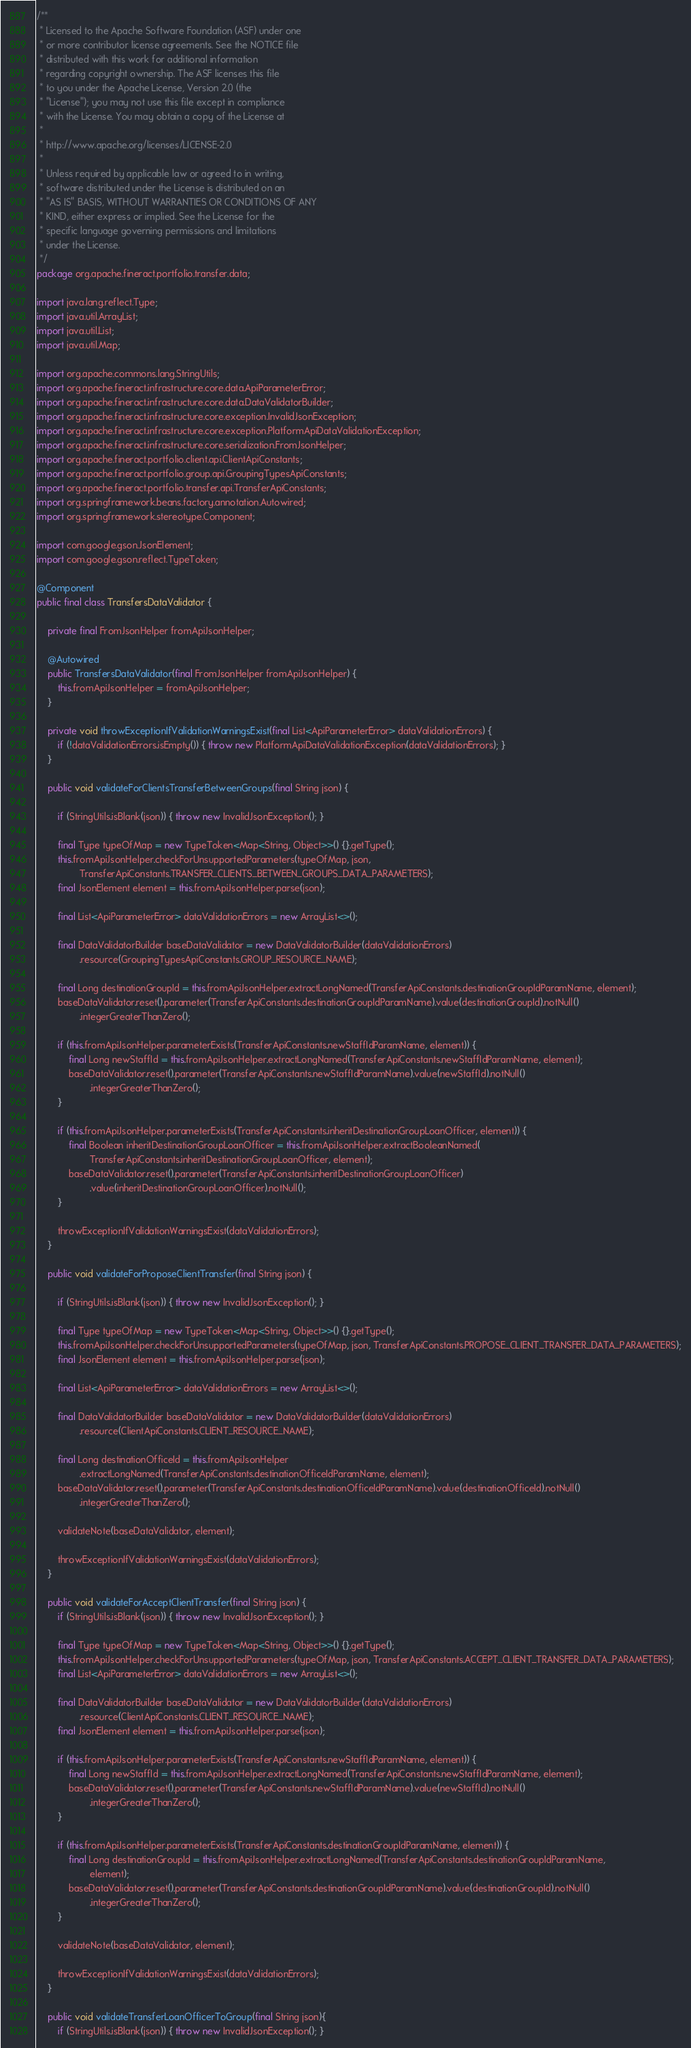<code> <loc_0><loc_0><loc_500><loc_500><_Java_>/**
 * Licensed to the Apache Software Foundation (ASF) under one
 * or more contributor license agreements. See the NOTICE file
 * distributed with this work for additional information
 * regarding copyright ownership. The ASF licenses this file
 * to you under the Apache License, Version 2.0 (the
 * "License"); you may not use this file except in compliance
 * with the License. You may obtain a copy of the License at
 *
 * http://www.apache.org/licenses/LICENSE-2.0
 *
 * Unless required by applicable law or agreed to in writing,
 * software distributed under the License is distributed on an
 * "AS IS" BASIS, WITHOUT WARRANTIES OR CONDITIONS OF ANY
 * KIND, either express or implied. See the License for the
 * specific language governing permissions and limitations
 * under the License.
 */
package org.apache.fineract.portfolio.transfer.data;

import java.lang.reflect.Type;
import java.util.ArrayList;
import java.util.List;
import java.util.Map;

import org.apache.commons.lang.StringUtils;
import org.apache.fineract.infrastructure.core.data.ApiParameterError;
import org.apache.fineract.infrastructure.core.data.DataValidatorBuilder;
import org.apache.fineract.infrastructure.core.exception.InvalidJsonException;
import org.apache.fineract.infrastructure.core.exception.PlatformApiDataValidationException;
import org.apache.fineract.infrastructure.core.serialization.FromJsonHelper;
import org.apache.fineract.portfolio.client.api.ClientApiConstants;
import org.apache.fineract.portfolio.group.api.GroupingTypesApiConstants;
import org.apache.fineract.portfolio.transfer.api.TransferApiConstants;
import org.springframework.beans.factory.annotation.Autowired;
import org.springframework.stereotype.Component;

import com.google.gson.JsonElement;
import com.google.gson.reflect.TypeToken;

@Component
public final class TransfersDataValidator {

    private final FromJsonHelper fromApiJsonHelper;

    @Autowired
    public TransfersDataValidator(final FromJsonHelper fromApiJsonHelper) {
        this.fromApiJsonHelper = fromApiJsonHelper;
    }

    private void throwExceptionIfValidationWarningsExist(final List<ApiParameterError> dataValidationErrors) {
        if (!dataValidationErrors.isEmpty()) { throw new PlatformApiDataValidationException(dataValidationErrors); }
    }

    public void validateForClientsTransferBetweenGroups(final String json) {

        if (StringUtils.isBlank(json)) { throw new InvalidJsonException(); }

        final Type typeOfMap = new TypeToken<Map<String, Object>>() {}.getType();
        this.fromApiJsonHelper.checkForUnsupportedParameters(typeOfMap, json,
                TransferApiConstants.TRANSFER_CLIENTS_BETWEEN_GROUPS_DATA_PARAMETERS);
        final JsonElement element = this.fromApiJsonHelper.parse(json);

        final List<ApiParameterError> dataValidationErrors = new ArrayList<>();

        final DataValidatorBuilder baseDataValidator = new DataValidatorBuilder(dataValidationErrors)
                .resource(GroupingTypesApiConstants.GROUP_RESOURCE_NAME);

        final Long destinationGroupId = this.fromApiJsonHelper.extractLongNamed(TransferApiConstants.destinationGroupIdParamName, element);
        baseDataValidator.reset().parameter(TransferApiConstants.destinationGroupIdParamName).value(destinationGroupId).notNull()
                .integerGreaterThanZero();

        if (this.fromApiJsonHelper.parameterExists(TransferApiConstants.newStaffIdParamName, element)) {
            final Long newStaffId = this.fromApiJsonHelper.extractLongNamed(TransferApiConstants.newStaffIdParamName, element);
            baseDataValidator.reset().parameter(TransferApiConstants.newStaffIdParamName).value(newStaffId).notNull()
                    .integerGreaterThanZero();
        }

        if (this.fromApiJsonHelper.parameterExists(TransferApiConstants.inheritDestinationGroupLoanOfficer, element)) {
            final Boolean inheritDestinationGroupLoanOfficer = this.fromApiJsonHelper.extractBooleanNamed(
                    TransferApiConstants.inheritDestinationGroupLoanOfficer, element);
            baseDataValidator.reset().parameter(TransferApiConstants.inheritDestinationGroupLoanOfficer)
                    .value(inheritDestinationGroupLoanOfficer).notNull();
        }

        throwExceptionIfValidationWarningsExist(dataValidationErrors);
    }

    public void validateForProposeClientTransfer(final String json) {

        if (StringUtils.isBlank(json)) { throw new InvalidJsonException(); }

        final Type typeOfMap = new TypeToken<Map<String, Object>>() {}.getType();
        this.fromApiJsonHelper.checkForUnsupportedParameters(typeOfMap, json, TransferApiConstants.PROPOSE_CLIENT_TRANSFER_DATA_PARAMETERS);
        final JsonElement element = this.fromApiJsonHelper.parse(json);

        final List<ApiParameterError> dataValidationErrors = new ArrayList<>();

        final DataValidatorBuilder baseDataValidator = new DataValidatorBuilder(dataValidationErrors)
                .resource(ClientApiConstants.CLIENT_RESOURCE_NAME);

        final Long destinationOfficeId = this.fromApiJsonHelper
                .extractLongNamed(TransferApiConstants.destinationOfficeIdParamName, element);
        baseDataValidator.reset().parameter(TransferApiConstants.destinationOfficeIdParamName).value(destinationOfficeId).notNull()
                .integerGreaterThanZero();

        validateNote(baseDataValidator, element);

        throwExceptionIfValidationWarningsExist(dataValidationErrors);
    }

    public void validateForAcceptClientTransfer(final String json) {
        if (StringUtils.isBlank(json)) { throw new InvalidJsonException(); }

        final Type typeOfMap = new TypeToken<Map<String, Object>>() {}.getType();
        this.fromApiJsonHelper.checkForUnsupportedParameters(typeOfMap, json, TransferApiConstants.ACCEPT_CLIENT_TRANSFER_DATA_PARAMETERS);
        final List<ApiParameterError> dataValidationErrors = new ArrayList<>();

        final DataValidatorBuilder baseDataValidator = new DataValidatorBuilder(dataValidationErrors)
                .resource(ClientApiConstants.CLIENT_RESOURCE_NAME);
        final JsonElement element = this.fromApiJsonHelper.parse(json);

        if (this.fromApiJsonHelper.parameterExists(TransferApiConstants.newStaffIdParamName, element)) {
            final Long newStaffId = this.fromApiJsonHelper.extractLongNamed(TransferApiConstants.newStaffIdParamName, element);
            baseDataValidator.reset().parameter(TransferApiConstants.newStaffIdParamName).value(newStaffId).notNull()
                    .integerGreaterThanZero();
        }

        if (this.fromApiJsonHelper.parameterExists(TransferApiConstants.destinationGroupIdParamName, element)) {
            final Long destinationGroupId = this.fromApiJsonHelper.extractLongNamed(TransferApiConstants.destinationGroupIdParamName,
                    element);
            baseDataValidator.reset().parameter(TransferApiConstants.destinationGroupIdParamName).value(destinationGroupId).notNull()
                    .integerGreaterThanZero();
        }

        validateNote(baseDataValidator, element);

        throwExceptionIfValidationWarningsExist(dataValidationErrors);
    }

    public void validateTransferLoanOfficerToGroup(final String json){
        if (StringUtils.isBlank(json)) { throw new InvalidJsonException(); }</code> 